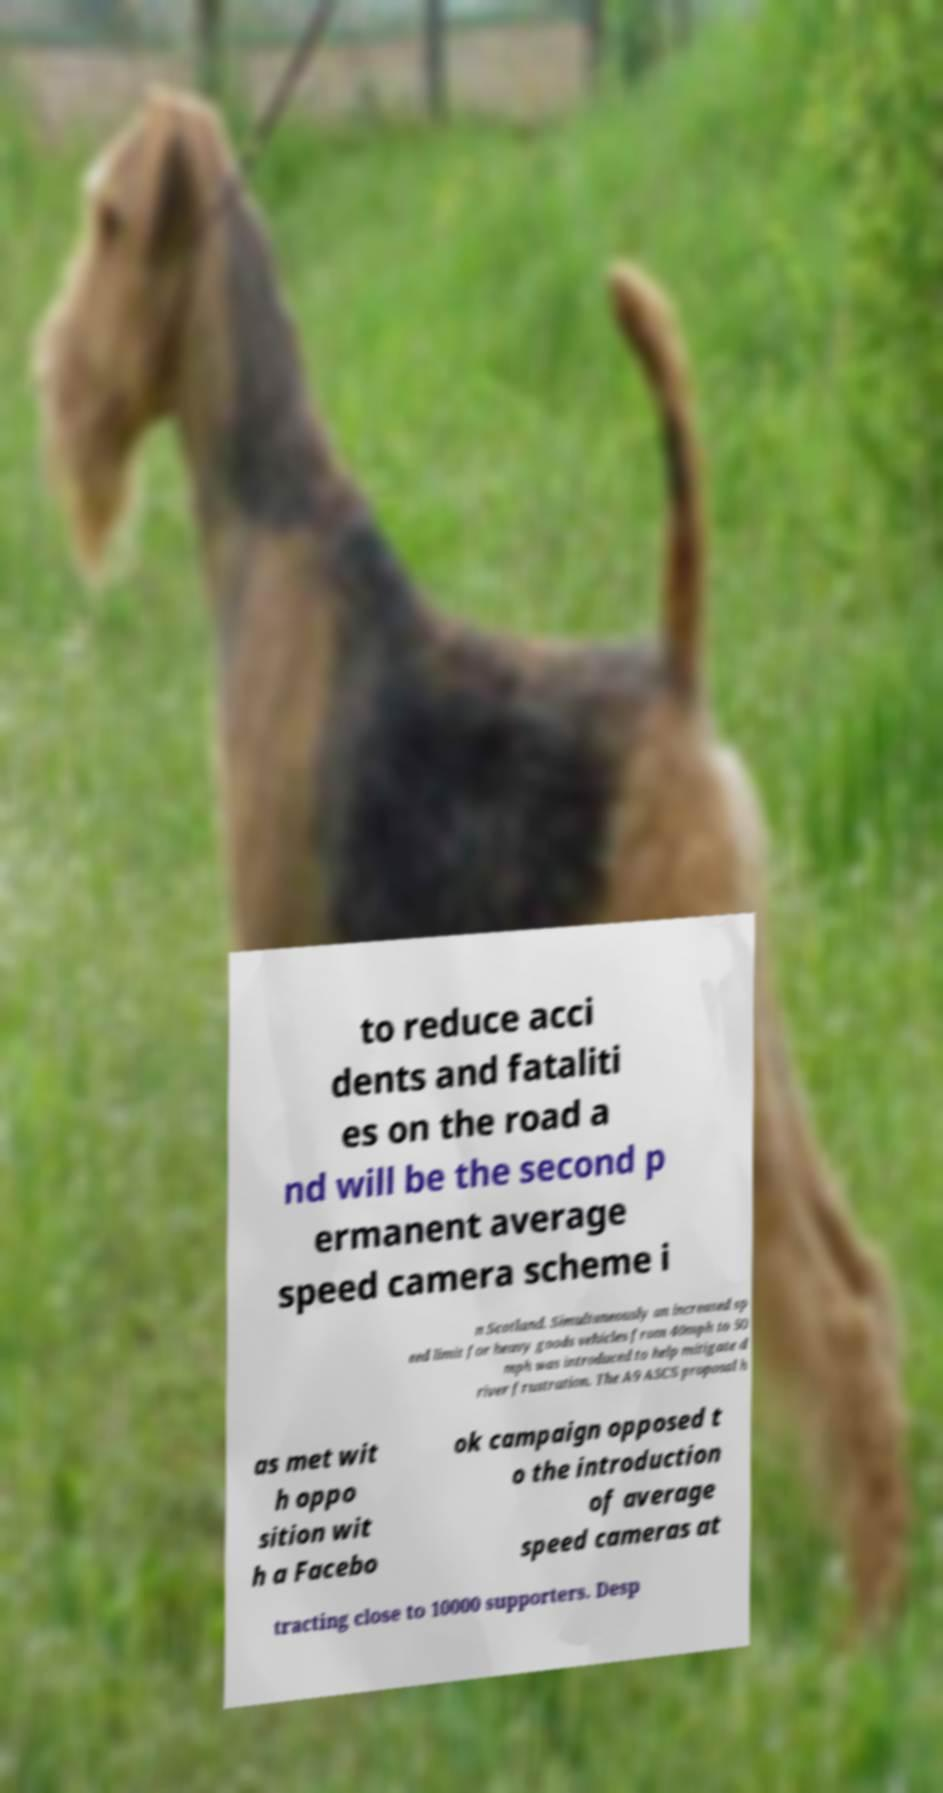Can you read and provide the text displayed in the image?This photo seems to have some interesting text. Can you extract and type it out for me? to reduce acci dents and fataliti es on the road a nd will be the second p ermanent average speed camera scheme i n Scotland. Simultaneously an increased sp eed limit for heavy goods vehicles from 40mph to 50 mph was introduced to help mitigate d river frustration. The A9 ASCS proposal h as met wit h oppo sition wit h a Facebo ok campaign opposed t o the introduction of average speed cameras at tracting close to 10000 supporters. Desp 